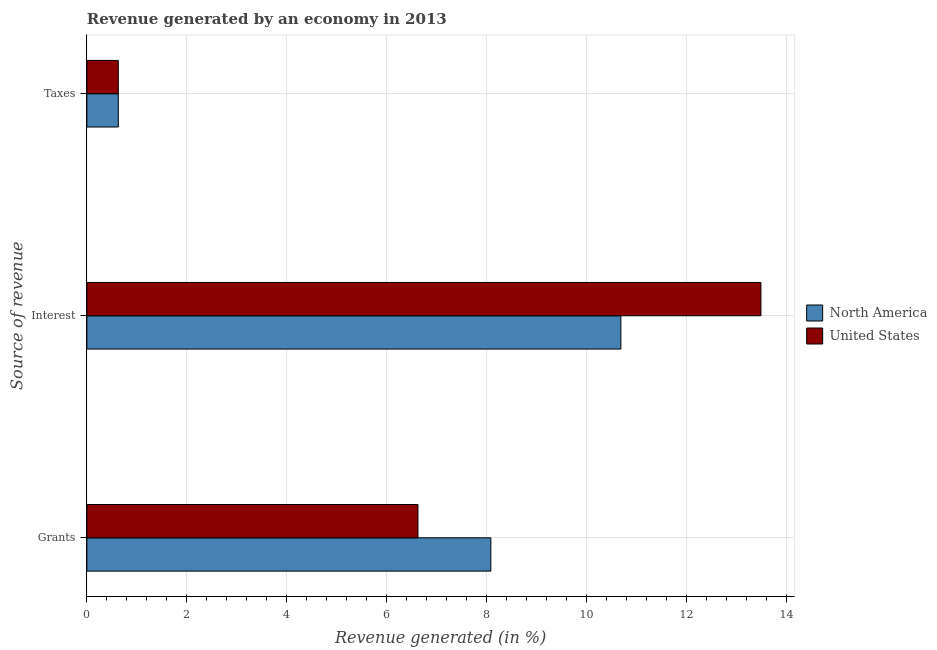Are the number of bars per tick equal to the number of legend labels?
Provide a short and direct response. Yes. How many bars are there on the 1st tick from the top?
Keep it short and to the point. 2. How many bars are there on the 2nd tick from the bottom?
Ensure brevity in your answer.  2. What is the label of the 2nd group of bars from the top?
Your answer should be compact. Interest. What is the percentage of revenue generated by taxes in United States?
Give a very brief answer. 0.63. Across all countries, what is the maximum percentage of revenue generated by taxes?
Your answer should be very brief. 0.63. Across all countries, what is the minimum percentage of revenue generated by interest?
Offer a very short reply. 10.69. In which country was the percentage of revenue generated by taxes maximum?
Ensure brevity in your answer.  North America. What is the total percentage of revenue generated by grants in the graph?
Your answer should be compact. 14.71. What is the difference between the percentage of revenue generated by taxes in United States and that in North America?
Give a very brief answer. 0. What is the difference between the percentage of revenue generated by taxes in North America and the percentage of revenue generated by grants in United States?
Your answer should be compact. -6. What is the average percentage of revenue generated by taxes per country?
Your answer should be compact. 0.63. What is the difference between the percentage of revenue generated by interest and percentage of revenue generated by taxes in North America?
Ensure brevity in your answer.  10.06. What is the ratio of the percentage of revenue generated by interest in United States to that in North America?
Your response must be concise. 1.26. Is the percentage of revenue generated by interest in United States less than that in North America?
Provide a succinct answer. No. What is the difference between the highest and the lowest percentage of revenue generated by interest?
Your answer should be very brief. 2.8. In how many countries, is the percentage of revenue generated by interest greater than the average percentage of revenue generated by interest taken over all countries?
Give a very brief answer. 1. Is the sum of the percentage of revenue generated by grants in United States and North America greater than the maximum percentage of revenue generated by interest across all countries?
Provide a short and direct response. Yes. What does the 2nd bar from the top in Interest represents?
Offer a terse response. North America. What does the 2nd bar from the bottom in Interest represents?
Give a very brief answer. United States. How many countries are there in the graph?
Provide a short and direct response. 2. What is the difference between two consecutive major ticks on the X-axis?
Make the answer very short. 2. Are the values on the major ticks of X-axis written in scientific E-notation?
Provide a succinct answer. No. Does the graph contain any zero values?
Provide a succinct answer. No. How are the legend labels stacked?
Provide a short and direct response. Vertical. What is the title of the graph?
Your response must be concise. Revenue generated by an economy in 2013. Does "Lower middle income" appear as one of the legend labels in the graph?
Make the answer very short. No. What is the label or title of the X-axis?
Your response must be concise. Revenue generated (in %). What is the label or title of the Y-axis?
Give a very brief answer. Source of revenue. What is the Revenue generated (in %) in North America in Grants?
Ensure brevity in your answer.  8.09. What is the Revenue generated (in %) of United States in Grants?
Provide a short and direct response. 6.63. What is the Revenue generated (in %) of North America in Interest?
Provide a succinct answer. 10.69. What is the Revenue generated (in %) of United States in Interest?
Your answer should be very brief. 13.49. What is the Revenue generated (in %) of North America in Taxes?
Make the answer very short. 0.63. What is the Revenue generated (in %) in United States in Taxes?
Keep it short and to the point. 0.63. Across all Source of revenue, what is the maximum Revenue generated (in %) in North America?
Offer a terse response. 10.69. Across all Source of revenue, what is the maximum Revenue generated (in %) of United States?
Make the answer very short. 13.49. Across all Source of revenue, what is the minimum Revenue generated (in %) in North America?
Your answer should be compact. 0.63. Across all Source of revenue, what is the minimum Revenue generated (in %) in United States?
Offer a terse response. 0.63. What is the total Revenue generated (in %) in North America in the graph?
Offer a terse response. 19.4. What is the total Revenue generated (in %) in United States in the graph?
Your response must be concise. 20.75. What is the difference between the Revenue generated (in %) of North America in Grants and that in Interest?
Provide a short and direct response. -2.6. What is the difference between the Revenue generated (in %) in United States in Grants and that in Interest?
Offer a terse response. -6.87. What is the difference between the Revenue generated (in %) of North America in Grants and that in Taxes?
Make the answer very short. 7.46. What is the difference between the Revenue generated (in %) in United States in Grants and that in Taxes?
Offer a terse response. 6. What is the difference between the Revenue generated (in %) in North America in Interest and that in Taxes?
Your answer should be compact. 10.06. What is the difference between the Revenue generated (in %) of United States in Interest and that in Taxes?
Offer a very short reply. 12.86. What is the difference between the Revenue generated (in %) of North America in Grants and the Revenue generated (in %) of United States in Interest?
Your response must be concise. -5.41. What is the difference between the Revenue generated (in %) of North America in Grants and the Revenue generated (in %) of United States in Taxes?
Your answer should be compact. 7.46. What is the difference between the Revenue generated (in %) in North America in Interest and the Revenue generated (in %) in United States in Taxes?
Your response must be concise. 10.06. What is the average Revenue generated (in %) of North America per Source of revenue?
Provide a succinct answer. 6.47. What is the average Revenue generated (in %) of United States per Source of revenue?
Provide a succinct answer. 6.92. What is the difference between the Revenue generated (in %) of North America and Revenue generated (in %) of United States in Grants?
Your answer should be compact. 1.46. What is the difference between the Revenue generated (in %) of North America and Revenue generated (in %) of United States in Interest?
Make the answer very short. -2.8. What is the difference between the Revenue generated (in %) in North America and Revenue generated (in %) in United States in Taxes?
Provide a succinct answer. 0. What is the ratio of the Revenue generated (in %) in North America in Grants to that in Interest?
Your response must be concise. 0.76. What is the ratio of the Revenue generated (in %) of United States in Grants to that in Interest?
Provide a succinct answer. 0.49. What is the ratio of the Revenue generated (in %) of North America in Grants to that in Taxes?
Keep it short and to the point. 12.86. What is the ratio of the Revenue generated (in %) in United States in Grants to that in Taxes?
Give a very brief answer. 10.54. What is the ratio of the Revenue generated (in %) in North America in Interest to that in Taxes?
Ensure brevity in your answer.  17. What is the ratio of the Revenue generated (in %) in United States in Interest to that in Taxes?
Give a very brief answer. 21.46. What is the difference between the highest and the second highest Revenue generated (in %) in North America?
Offer a very short reply. 2.6. What is the difference between the highest and the second highest Revenue generated (in %) in United States?
Your response must be concise. 6.87. What is the difference between the highest and the lowest Revenue generated (in %) of North America?
Offer a terse response. 10.06. What is the difference between the highest and the lowest Revenue generated (in %) of United States?
Make the answer very short. 12.86. 